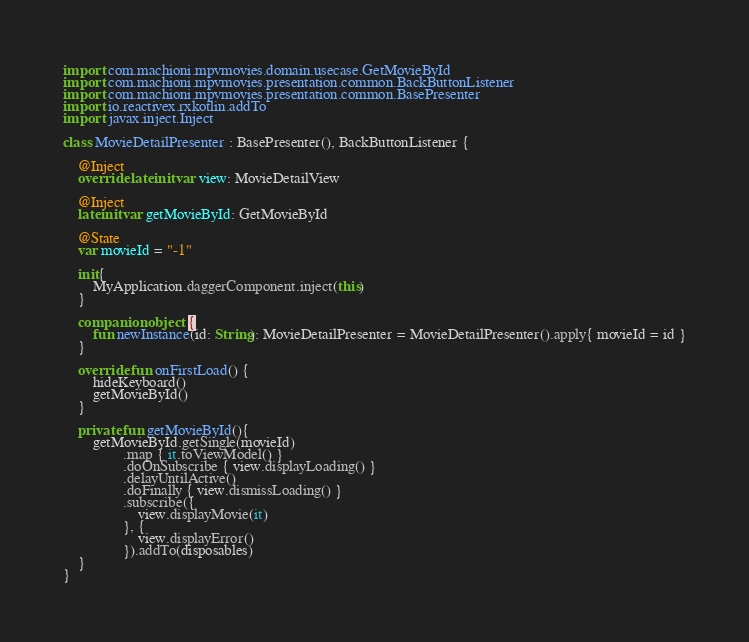Convert code to text. <code><loc_0><loc_0><loc_500><loc_500><_Kotlin_>import com.machioni.mpvmovies.domain.usecase.GetMovieById
import com.machioni.mpvmovies.presentation.common.BackButtonListener
import com.machioni.mpvmovies.presentation.common.BasePresenter
import io.reactivex.rxkotlin.addTo
import javax.inject.Inject

class MovieDetailPresenter : BasePresenter(), BackButtonListener {

    @Inject
    override lateinit var view: MovieDetailView

    @Inject
    lateinit var getMovieById: GetMovieById

    @State
    var movieId = "-1"

    init{
        MyApplication.daggerComponent.inject(this)
    }

    companion object {
        fun newInstance(id: String): MovieDetailPresenter = MovieDetailPresenter().apply{ movieId = id }
    }

    override fun onFirstLoad() {
        hideKeyboard()
        getMovieById()
    }

    private fun getMovieById(){
        getMovieById.getSingle(movieId)
                .map { it.toViewModel() }
                .doOnSubscribe { view.displayLoading() }
                .delayUntilActive()
                .doFinally { view.dismissLoading() }
                .subscribe({
                    view.displayMovie(it)
                }, {
                    view.displayError()
                }).addTo(disposables)
    }
}</code> 